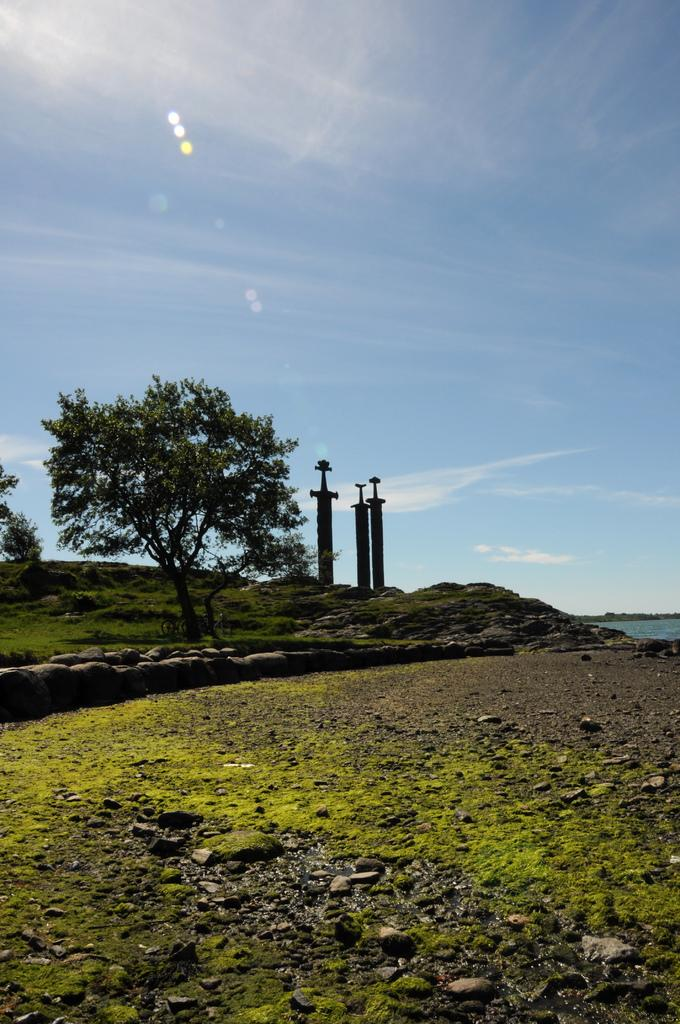What type of surface can be seen in the image? There is ground visible in the image. What is present on the ground? There are objects on the ground. What type of vegetation is in the image? There is grass in the image. What other natural elements can be seen in the image? There are trees in the image. What man-made structures are present in the image? There are poles in the image. What else can be seen in the image besides the ground and objects? There is water visible in the image. What is visible in the sky? The sky is visible in the image, and there are clouds in the sky. Can you tell me the price of the brush on the receipt in the image? There is no brush or receipt present in the image. What type of farming equipment is being used in the image? There is no farming equipment, such as a plough, present in the image. 